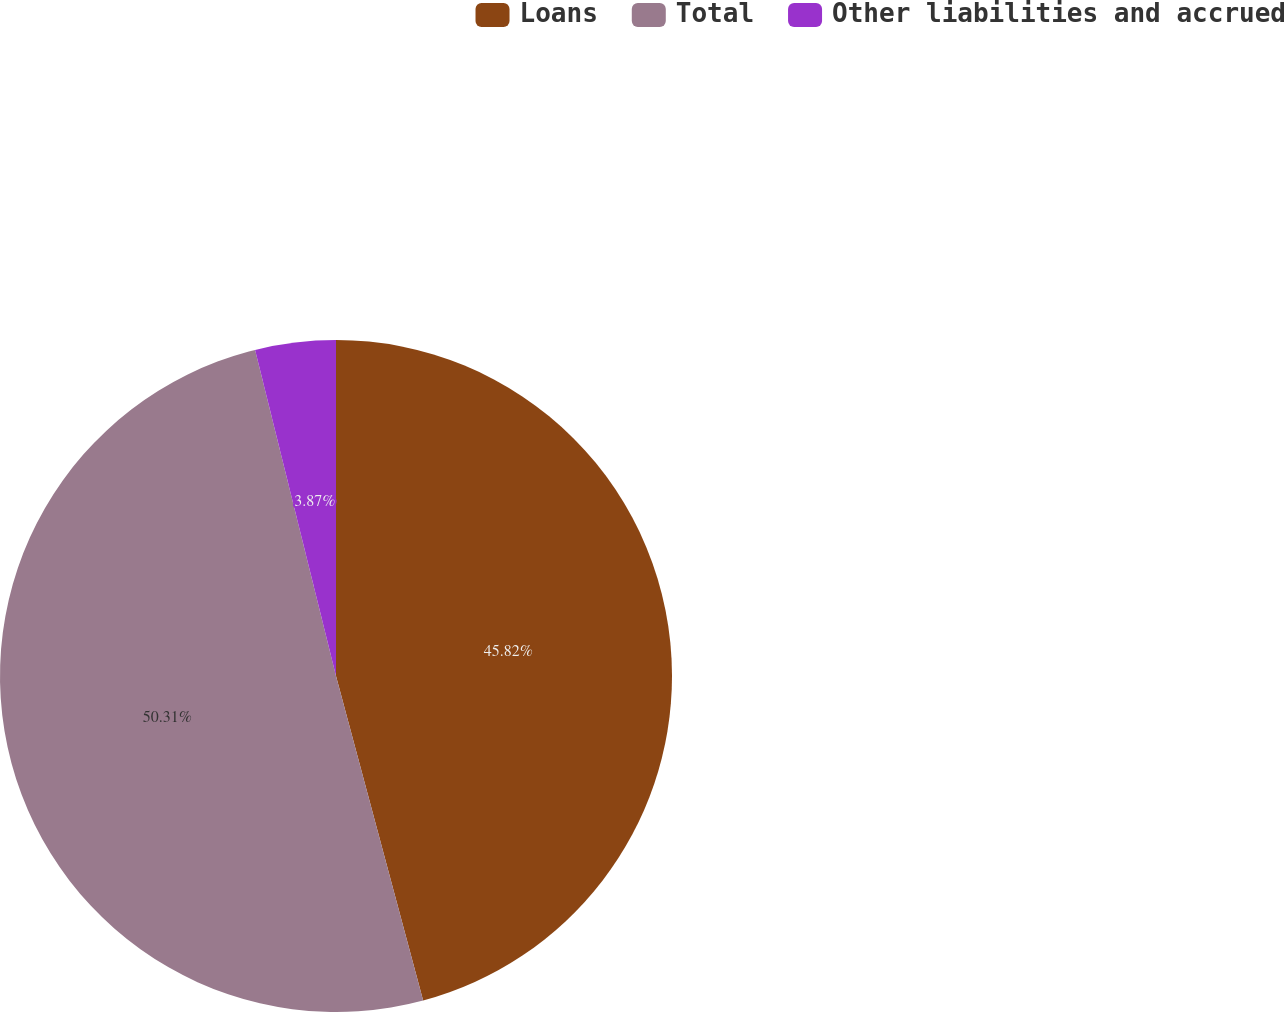Convert chart to OTSL. <chart><loc_0><loc_0><loc_500><loc_500><pie_chart><fcel>Loans<fcel>Total<fcel>Other liabilities and accrued<nl><fcel>45.82%<fcel>50.3%<fcel>3.87%<nl></chart> 